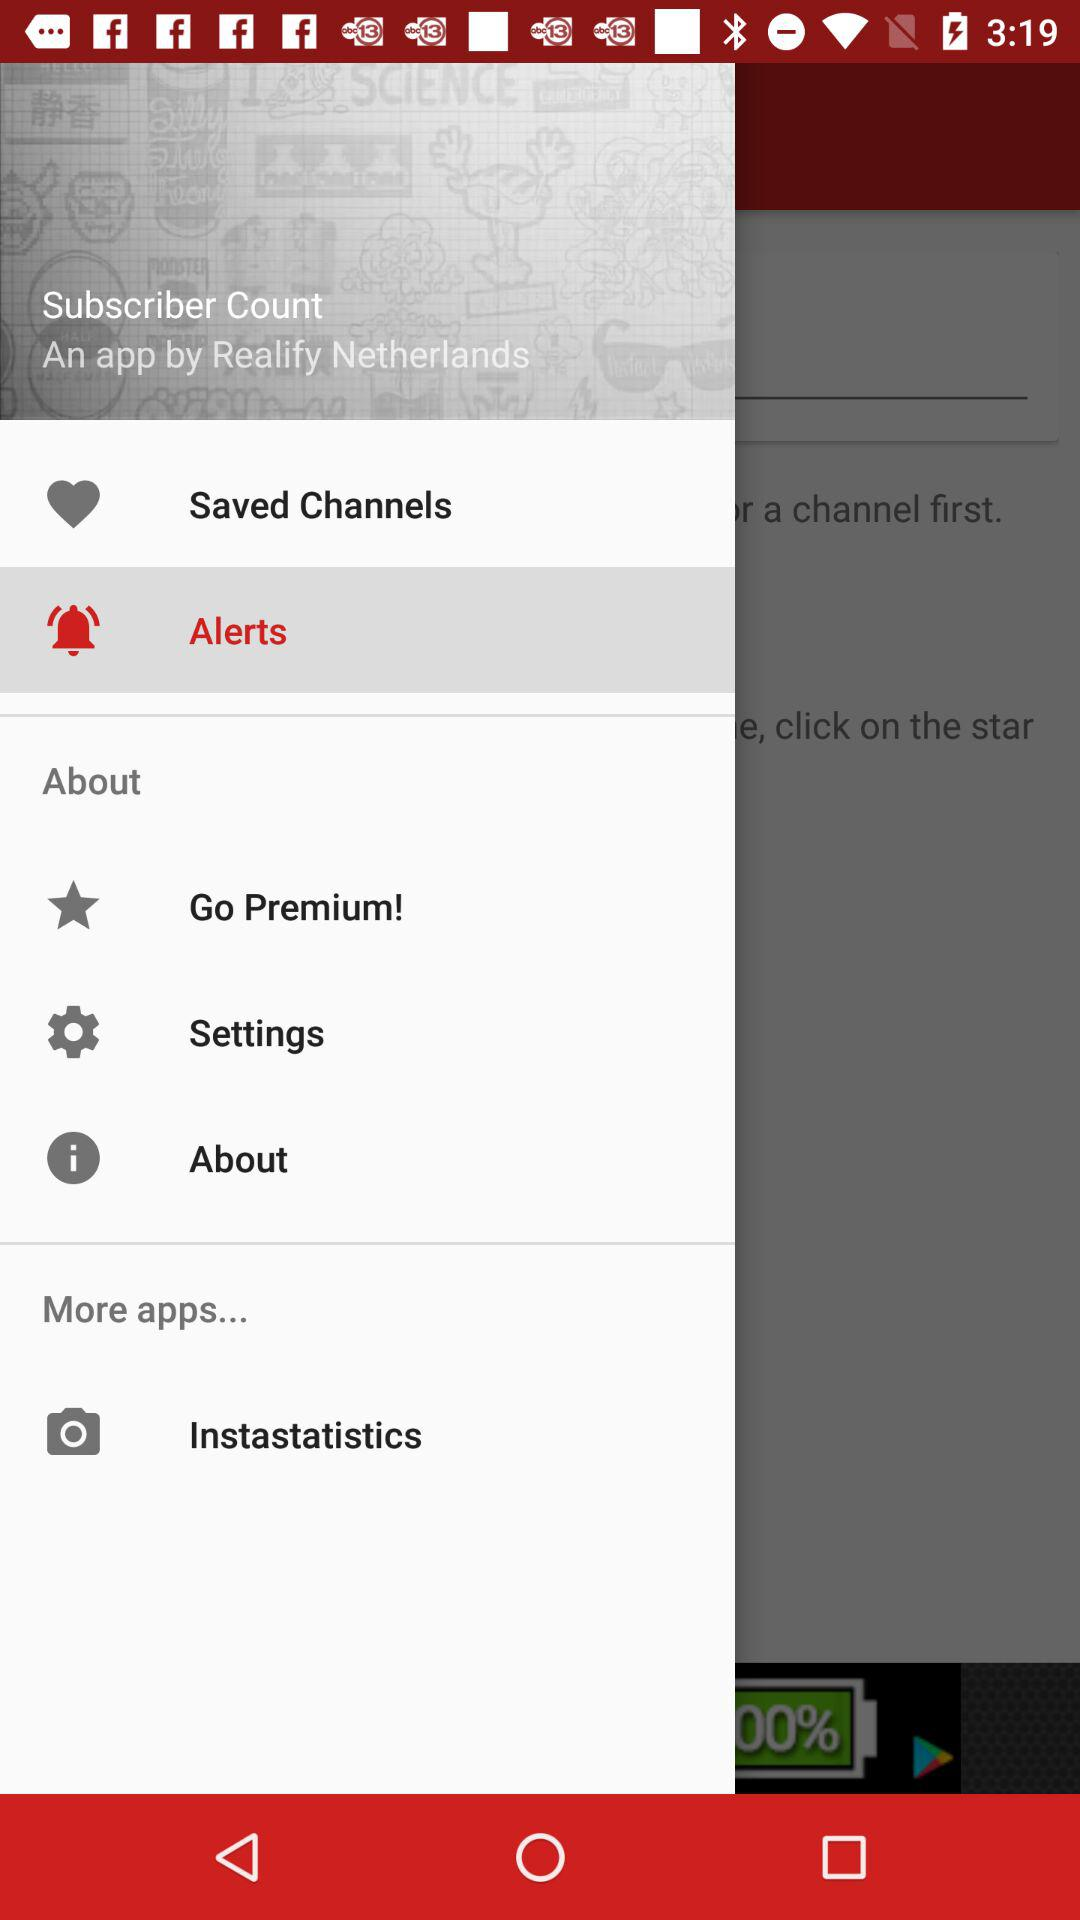Which item is selected? The selected item is "Alerts". 